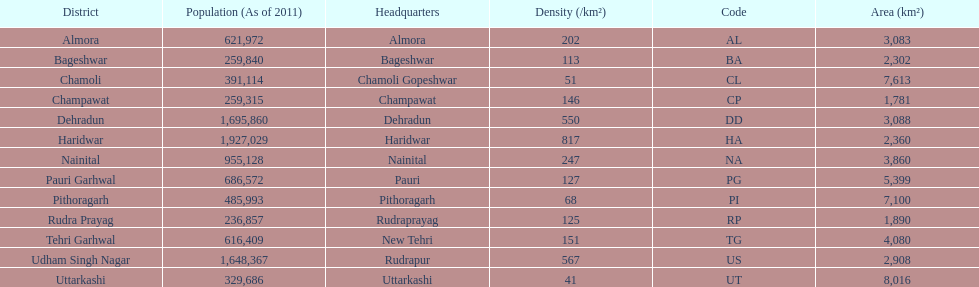What is the next most populous district after haridwar? Dehradun. 